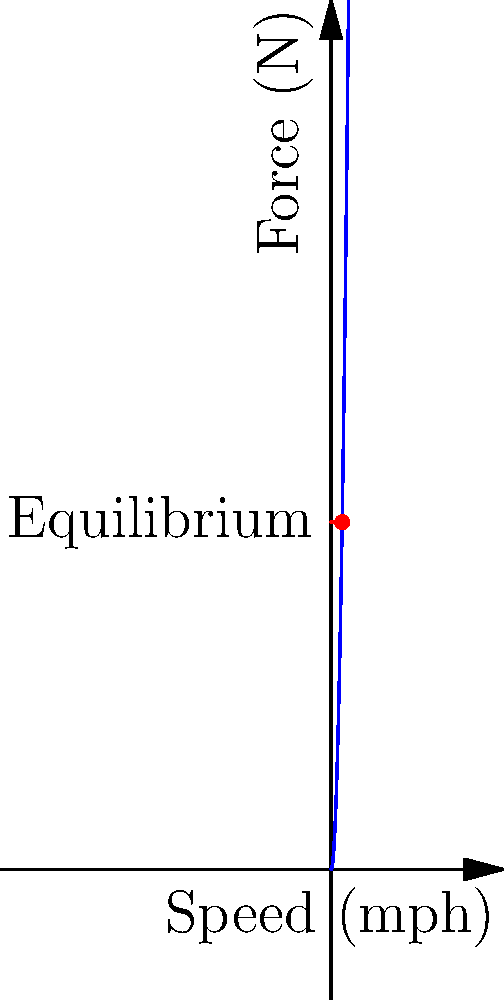Analyze the force vector diagram for a drag racer. At what speed (in mph) does the drag force equal the thrust force, and what does this point represent in terms of the vehicle's performance? To solve this problem, we need to follow these steps:

1. Understand the forces:
   - The blue curve represents the drag force, which increases quadratically with speed.
   - The red line represents the thrust force, which is constant at 2000 N.

2. Identify the equilibrium point:
   - The equilibrium point is where the drag force equals the thrust force.
   - This occurs at the intersection of the blue curve and the red line.

3. Determine the speed at equilibrium:
   - From the graph, we can see that the intersection occurs at approximately 63.2 mph.

4. Interpret the meaning of this point:
   - At speeds below 63.2 mph, thrust force > drag force, so the vehicle accelerates.
   - At 63.2 mph, thrust force = drag force, so the vehicle maintains constant speed.
   - Above 63.2 mph, drag force > thrust force, so the vehicle decelerates.

5. Conclude:
   - The speed of 63.2 mph represents the maximum sustainable speed of the drag racer under these conditions.
   - This is often referred to as the terminal velocity or top speed of the vehicle.
Answer: 63.2 mph; terminal velocity 